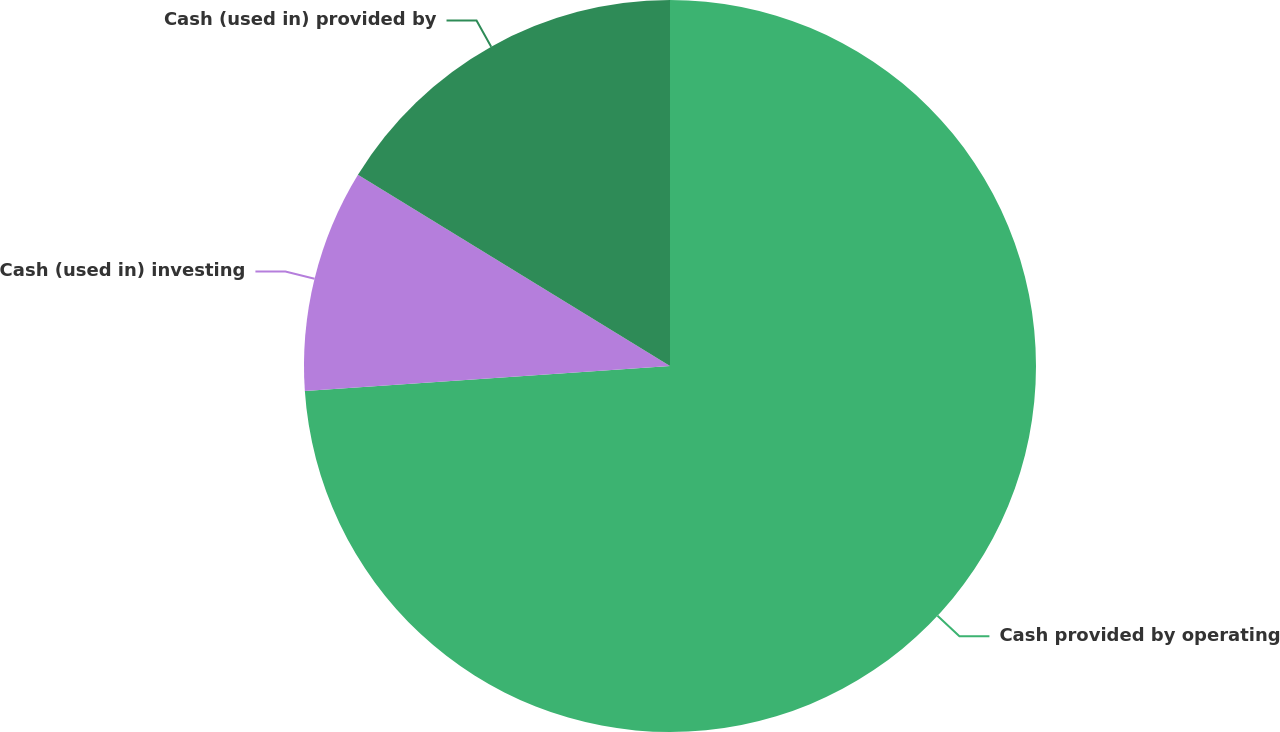<chart> <loc_0><loc_0><loc_500><loc_500><pie_chart><fcel>Cash provided by operating<fcel>Cash (used in) investing<fcel>Cash (used in) provided by<nl><fcel>73.92%<fcel>9.84%<fcel>16.25%<nl></chart> 